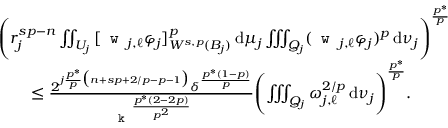Convert formula to latex. <formula><loc_0><loc_0><loc_500><loc_500>\begin{array} { r l } & { \left ( r _ { j } ^ { s p - n } \iint _ { U _ { j } } \, [ w _ { j , \ell } \varphi _ { j } ] _ { W ^ { s , p } ( B _ { j } ) } ^ { p } \, d \mu _ { j } \iiint _ { Q _ { j } } ( w _ { j , \ell } \varphi _ { j } ) ^ { p } \, d \nu _ { j } \right ) ^ { \frac { p ^ { * } } { p } } } \\ & { \quad \leq \frac { 2 ^ { j \frac { p ^ { * } } { p } \left ( n + s p + 2 / p - p - 1 \right ) } \delta ^ { \frac { p ^ { * } ( 1 - p ) } { p } } } { k ^ { \frac { p ^ { * } ( 2 - 2 p ) } { p ^ { 2 } } } } \left ( \iiint _ { Q _ { j } } \omega _ { j , \ell } ^ { 2 / p } \, d \nu _ { j } \right ) ^ { \frac { p ^ { * } } { p } } . } \end{array}</formula> 